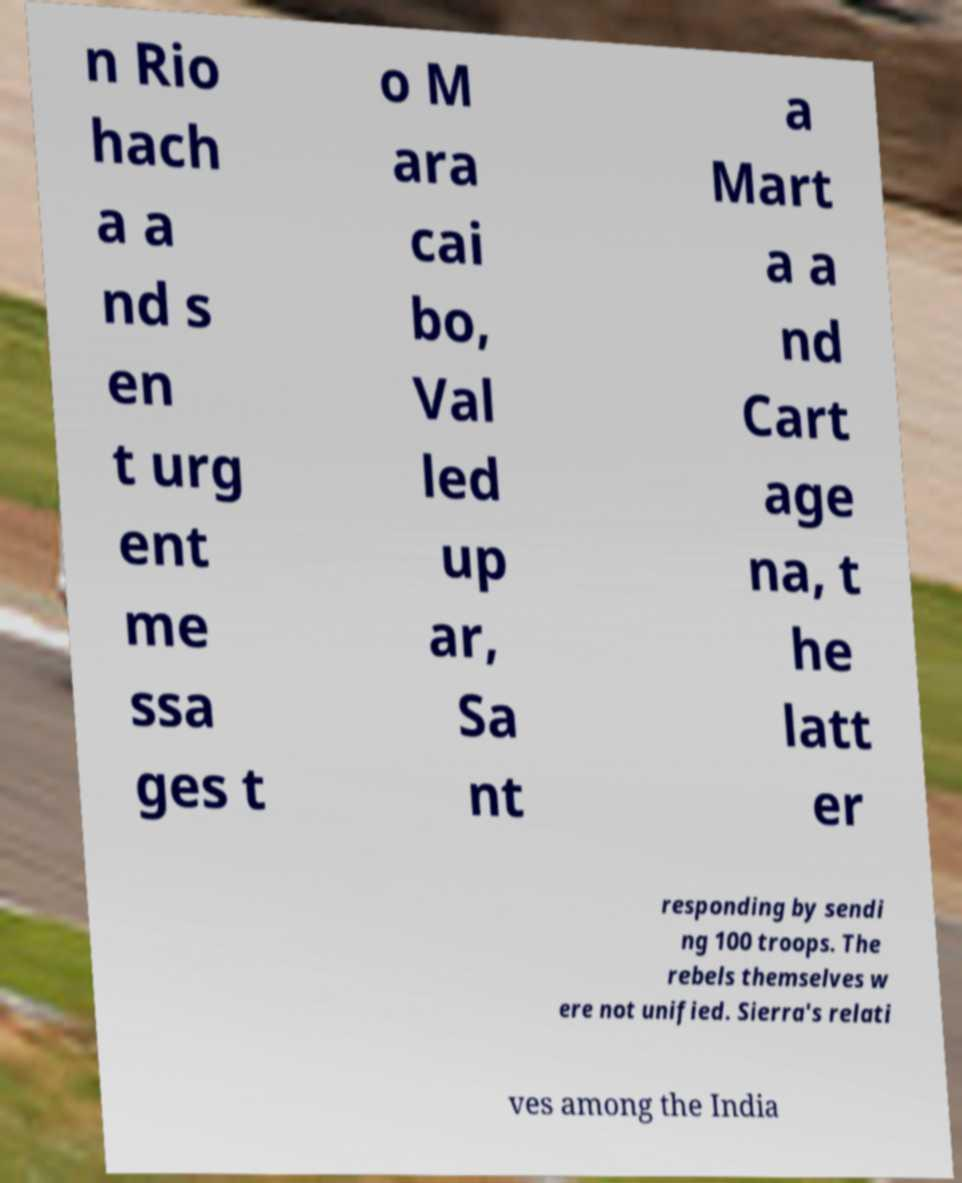Could you assist in decoding the text presented in this image and type it out clearly? n Rio hach a a nd s en t urg ent me ssa ges t o M ara cai bo, Val led up ar, Sa nt a Mart a a nd Cart age na, t he latt er responding by sendi ng 100 troops. The rebels themselves w ere not unified. Sierra's relati ves among the India 